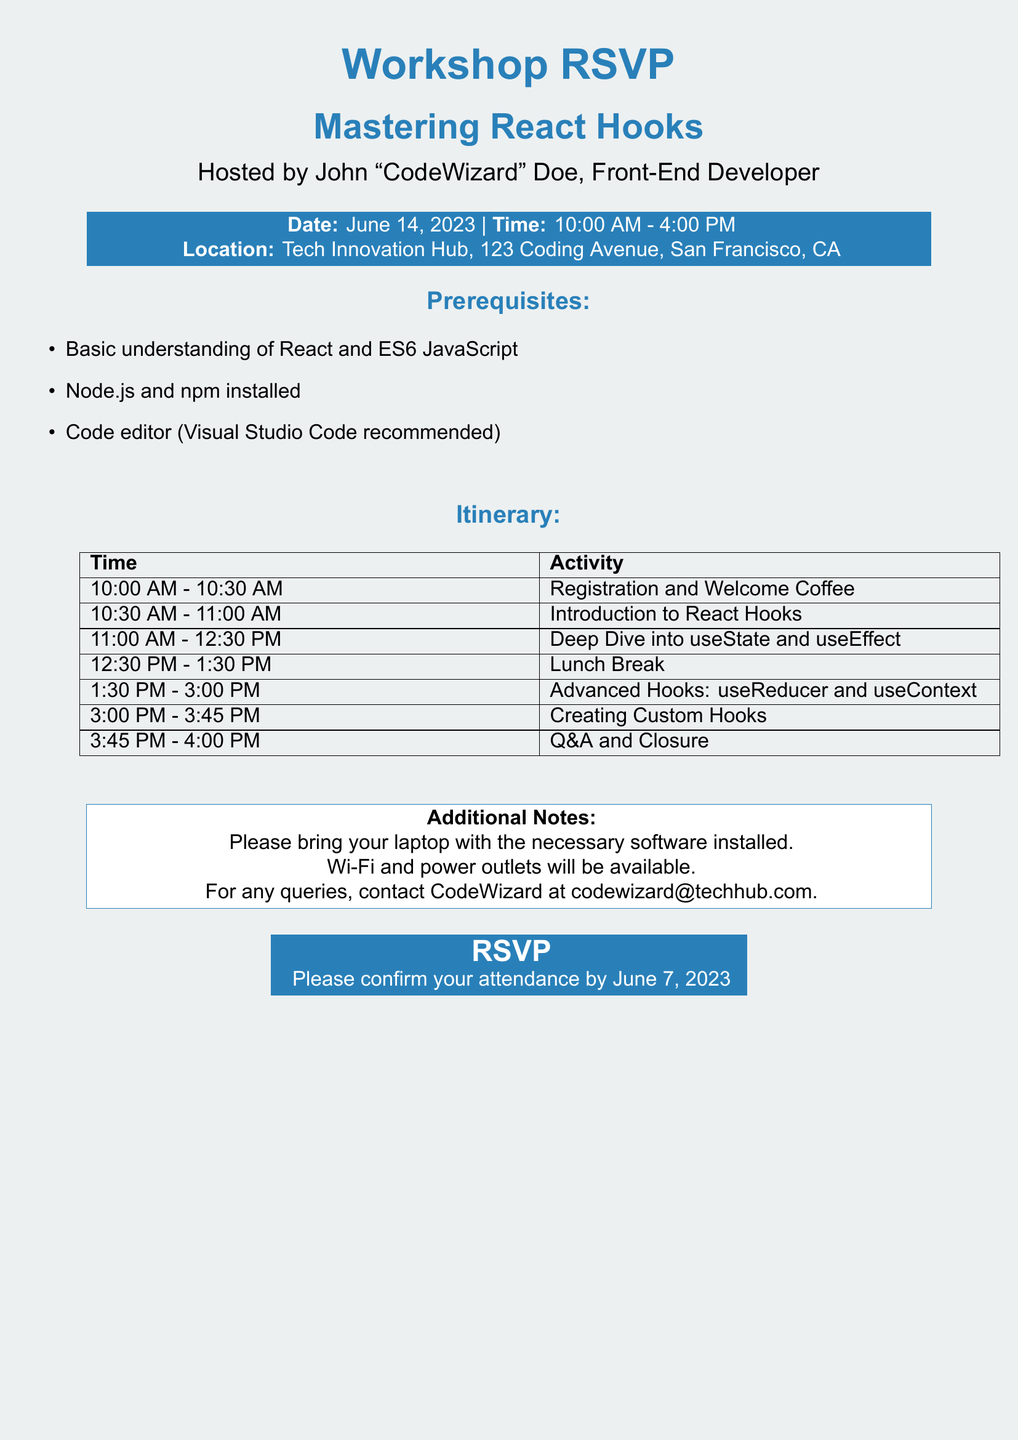What is the date of the workshop? The date of the workshop is mentioned in the document as June 14, 2023.
Answer: June 14, 2023 What are the prerequisites for attending? The prerequisites are listed as basic understanding of React, Node.js, and a code editor.
Answer: Basic understanding of React and ES6 JavaScript, Node.js and npm installed, Code editor (Visual Studio Code recommended) What time does the workshop start? The workshop start time is provided clearly in the itinerary section of the document as 10:00 AM.
Answer: 10:00 AM What is the location of the workshop? The location is specified in the document as Tech Innovation Hub, 123 Coding Avenue, San Francisco, CA.
Answer: Tech Innovation Hub, 123 Coding Avenue, San Francisco, CA What activities are planned from 10:30 AM to 12:30 PM? The activities for this time slot include Introduction to React Hooks and a Deep Dive into useState and useEffect.
Answer: Introduction to React Hooks, Deep Dive into useState and useEffect Who is hosting the workshop? The host of the workshop is mentioned as John "CodeWizard" Doe.
Answer: John "CodeWizard" Doe What is the duration of the lunch break? The lunch break is indicated in the itinerary as starting at 12:30 PM and ending at 1:30 PM, which totals one hour.
Answer: One hour When is the deadline for RSVPing? The RSVP deadline is stated in the RSVP section, which is June 7, 2023.
Answer: June 7, 2023 Is Wi-Fi available at the workshop? The Additional Notes section clearly states that Wi-Fi will be available.
Answer: Yes 